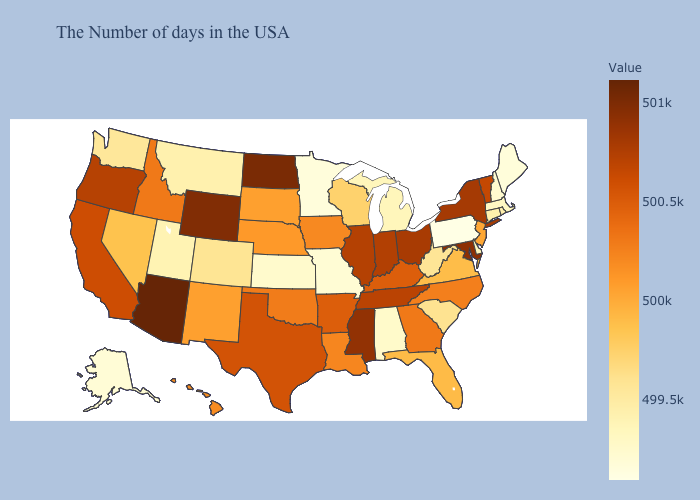Does the map have missing data?
Write a very short answer. No. Among the states that border Maryland , which have the lowest value?
Write a very short answer. Pennsylvania. Does Arizona have the highest value in the USA?
Write a very short answer. Yes. Which states have the lowest value in the South?
Quick response, please. Alabama. Does New Jersey have a lower value than Michigan?
Keep it brief. No. Does Indiana have a lower value than Florida?
Short answer required. No. 